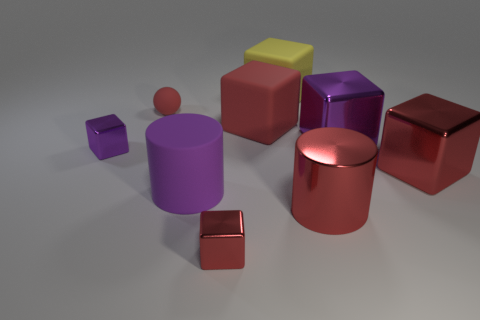Subtract all green balls. How many red cubes are left? 3 Subtract all purple blocks. How many blocks are left? 4 Subtract all tiny cubes. How many cubes are left? 4 Subtract 3 cubes. How many cubes are left? 3 Subtract all green cubes. Subtract all cyan spheres. How many cubes are left? 6 Add 1 gray metal things. How many objects exist? 10 Subtract all spheres. How many objects are left? 8 Subtract all brown objects. Subtract all small red rubber spheres. How many objects are left? 8 Add 9 large purple cylinders. How many large purple cylinders are left? 10 Add 3 small rubber balls. How many small rubber balls exist? 4 